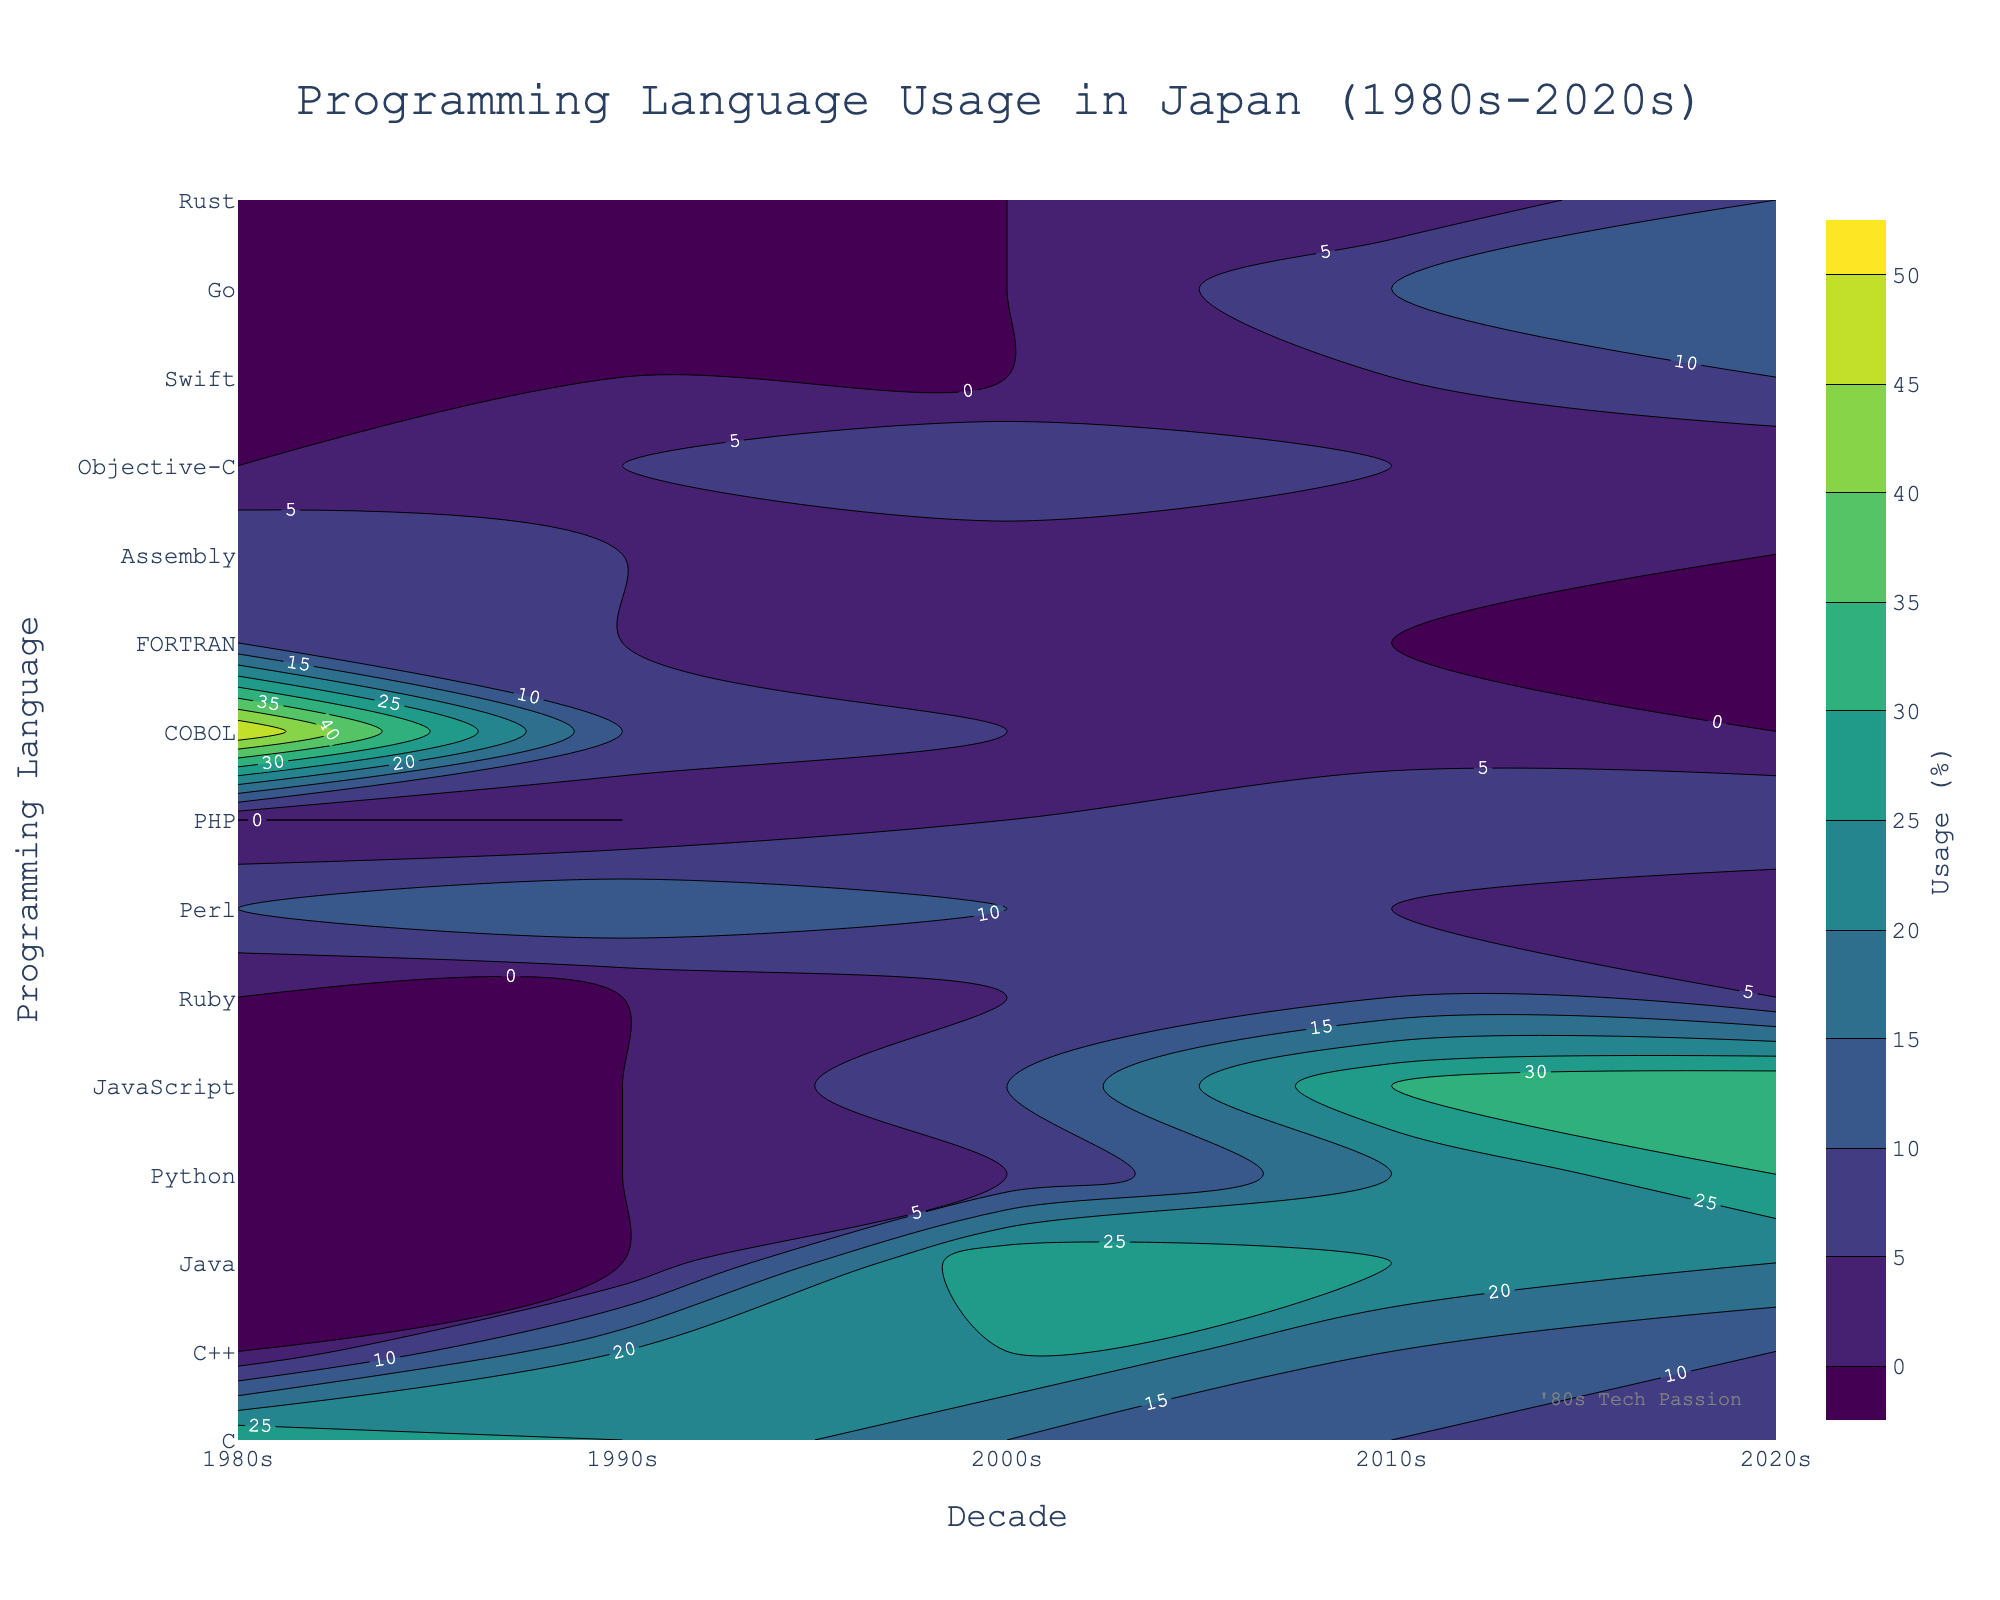What's the title of this figure? The title is prominently displayed at the top of the figure.
Answer: Programming Language Usage in Japan (1980s-2020s) Which programming language had the highest usage percentage in the 1980s? Locate the decade 1980s on the x-axis and find the programming language along the y-axis with the peak contour value.
Answer: COBOL How did JavaScript's usage change from the 2000s to the 2020s? Follow the contour lines for JavaScript from the 2000s to the 2020s to observe the trend in percentage use.
Answer: It increased from 10% to 35% What is the usage percentage of Python in the 2010s? Find the point where the 2010s (x-axis) and Python (y-axis) intersect and check the contour label.
Answer: 20% Which programming language shows a significant decline in usage from the 1980s to the 2020s? Identify languages with high contours in the 1980s and low or zero contours in the 2020s.
Answer: COBOL Which languages show an increasing trend from the 2000s to the 2020s? Look for languages with ascending contours between these decades.
Answer: Python, JavaScript, Go, Rust Compare the usage of C and C++ in the 2010s. Which one had higher usage? Locate the 2010s on the x-axis and compare the contour values of C and C++.
Answer: C++ What is the average usage percentage of all languages in the 2020s? Sum the percentages of all languages in the 2020s and divide by the number of languages. The data provided: (5+10+20+30+35+5+1+10+0+0+0+1+10+15+10)/15.
Answer: 10% Which decade had the highest diversity in language usage? Compare the spread and variation of contour values across all decades.
Answer: 2020s How did the usage of Objective-C change from the 1990s to the 2020s? Follow the contour lines for Objective-C across these decades to observe the trend.
Answer: It increased in the 1990s and 2000s, then decreased by the 2020s 